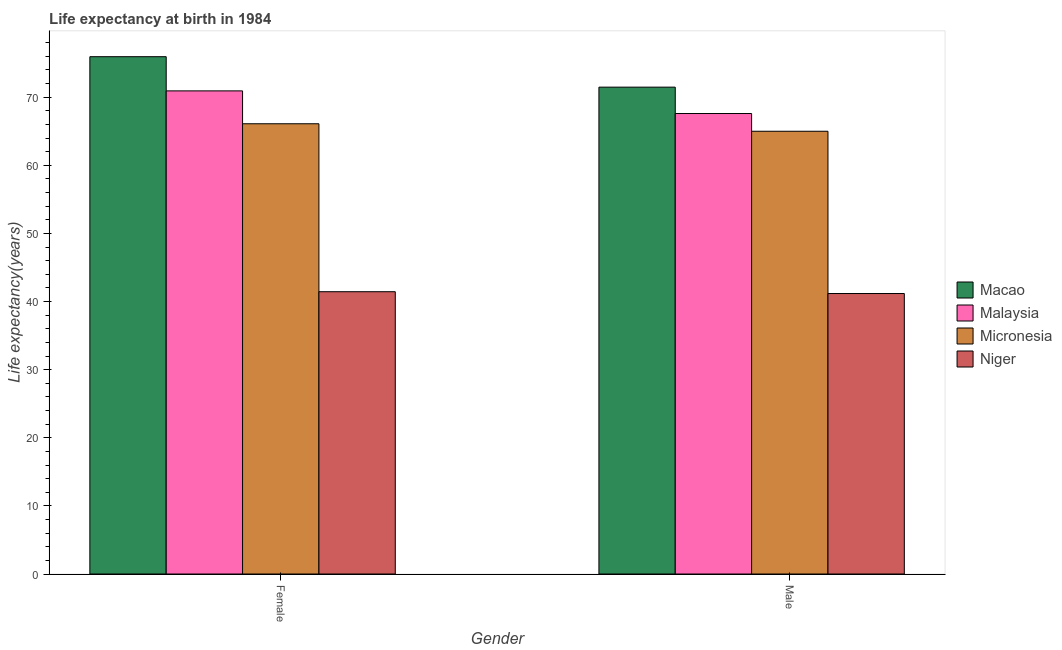How many different coloured bars are there?
Provide a succinct answer. 4. Are the number of bars on each tick of the X-axis equal?
Offer a terse response. Yes. How many bars are there on the 1st tick from the left?
Provide a succinct answer. 4. How many bars are there on the 2nd tick from the right?
Keep it short and to the point. 4. What is the label of the 2nd group of bars from the left?
Provide a succinct answer. Male. What is the life expectancy(male) in Niger?
Your answer should be compact. 41.18. Across all countries, what is the maximum life expectancy(female)?
Your answer should be compact. 75.95. Across all countries, what is the minimum life expectancy(female)?
Your answer should be very brief. 41.44. In which country was the life expectancy(male) maximum?
Provide a succinct answer. Macao. In which country was the life expectancy(male) minimum?
Your answer should be compact. Niger. What is the total life expectancy(male) in the graph?
Make the answer very short. 245.27. What is the difference between the life expectancy(male) in Macao and that in Micronesia?
Give a very brief answer. 6.48. What is the difference between the life expectancy(female) in Niger and the life expectancy(male) in Malaysia?
Offer a very short reply. -26.16. What is the average life expectancy(male) per country?
Keep it short and to the point. 61.32. What is the difference between the life expectancy(female) and life expectancy(male) in Micronesia?
Make the answer very short. 1.1. What is the ratio of the life expectancy(male) in Macao to that in Malaysia?
Provide a succinct answer. 1.06. What does the 3rd bar from the left in Male represents?
Your answer should be compact. Micronesia. What does the 4th bar from the right in Male represents?
Your answer should be compact. Macao. How many bars are there?
Your answer should be very brief. 8. Are all the bars in the graph horizontal?
Your answer should be very brief. No. Does the graph contain any zero values?
Your response must be concise. No. Does the graph contain grids?
Keep it short and to the point. No. Where does the legend appear in the graph?
Your answer should be compact. Center right. What is the title of the graph?
Your answer should be very brief. Life expectancy at birth in 1984. Does "Argentina" appear as one of the legend labels in the graph?
Keep it short and to the point. No. What is the label or title of the Y-axis?
Offer a very short reply. Life expectancy(years). What is the Life expectancy(years) in Macao in Female?
Ensure brevity in your answer.  75.95. What is the Life expectancy(years) in Malaysia in Female?
Give a very brief answer. 70.93. What is the Life expectancy(years) in Micronesia in Female?
Offer a very short reply. 66.1. What is the Life expectancy(years) of Niger in Female?
Make the answer very short. 41.44. What is the Life expectancy(years) in Macao in Male?
Provide a succinct answer. 71.48. What is the Life expectancy(years) of Malaysia in Male?
Provide a succinct answer. 67.61. What is the Life expectancy(years) in Micronesia in Male?
Provide a succinct answer. 65. What is the Life expectancy(years) in Niger in Male?
Give a very brief answer. 41.18. Across all Gender, what is the maximum Life expectancy(years) in Macao?
Your response must be concise. 75.95. Across all Gender, what is the maximum Life expectancy(years) in Malaysia?
Make the answer very short. 70.93. Across all Gender, what is the maximum Life expectancy(years) in Micronesia?
Keep it short and to the point. 66.1. Across all Gender, what is the maximum Life expectancy(years) of Niger?
Your answer should be very brief. 41.44. Across all Gender, what is the minimum Life expectancy(years) of Macao?
Provide a short and direct response. 71.48. Across all Gender, what is the minimum Life expectancy(years) of Malaysia?
Keep it short and to the point. 67.61. Across all Gender, what is the minimum Life expectancy(years) in Micronesia?
Give a very brief answer. 65. Across all Gender, what is the minimum Life expectancy(years) of Niger?
Your answer should be very brief. 41.18. What is the total Life expectancy(years) in Macao in the graph?
Your response must be concise. 147.43. What is the total Life expectancy(years) in Malaysia in the graph?
Your answer should be very brief. 138.54. What is the total Life expectancy(years) of Micronesia in the graph?
Your response must be concise. 131.11. What is the total Life expectancy(years) of Niger in the graph?
Keep it short and to the point. 82.62. What is the difference between the Life expectancy(years) in Macao in Female and that in Male?
Provide a short and direct response. 4.47. What is the difference between the Life expectancy(years) of Malaysia in Female and that in Male?
Provide a short and direct response. 3.32. What is the difference between the Life expectancy(years) of Micronesia in Female and that in Male?
Give a very brief answer. 1.1. What is the difference between the Life expectancy(years) of Niger in Female and that in Male?
Offer a very short reply. 0.27. What is the difference between the Life expectancy(years) of Macao in Female and the Life expectancy(years) of Malaysia in Male?
Provide a succinct answer. 8.34. What is the difference between the Life expectancy(years) of Macao in Female and the Life expectancy(years) of Micronesia in Male?
Give a very brief answer. 10.95. What is the difference between the Life expectancy(years) of Macao in Female and the Life expectancy(years) of Niger in Male?
Offer a terse response. 34.77. What is the difference between the Life expectancy(years) of Malaysia in Female and the Life expectancy(years) of Micronesia in Male?
Give a very brief answer. 5.93. What is the difference between the Life expectancy(years) in Malaysia in Female and the Life expectancy(years) in Niger in Male?
Ensure brevity in your answer.  29.75. What is the difference between the Life expectancy(years) in Micronesia in Female and the Life expectancy(years) in Niger in Male?
Provide a short and direct response. 24.92. What is the average Life expectancy(years) in Macao per Gender?
Provide a succinct answer. 73.71. What is the average Life expectancy(years) of Malaysia per Gender?
Your answer should be compact. 69.27. What is the average Life expectancy(years) in Micronesia per Gender?
Your answer should be very brief. 65.55. What is the average Life expectancy(years) of Niger per Gender?
Provide a short and direct response. 41.31. What is the difference between the Life expectancy(years) in Macao and Life expectancy(years) in Malaysia in Female?
Offer a terse response. 5.02. What is the difference between the Life expectancy(years) of Macao and Life expectancy(years) of Micronesia in Female?
Offer a very short reply. 9.85. What is the difference between the Life expectancy(years) in Macao and Life expectancy(years) in Niger in Female?
Offer a very short reply. 34.51. What is the difference between the Life expectancy(years) of Malaysia and Life expectancy(years) of Micronesia in Female?
Your response must be concise. 4.83. What is the difference between the Life expectancy(years) of Malaysia and Life expectancy(years) of Niger in Female?
Give a very brief answer. 29.49. What is the difference between the Life expectancy(years) in Micronesia and Life expectancy(years) in Niger in Female?
Your answer should be very brief. 24.66. What is the difference between the Life expectancy(years) of Macao and Life expectancy(years) of Malaysia in Male?
Provide a succinct answer. 3.87. What is the difference between the Life expectancy(years) in Macao and Life expectancy(years) in Micronesia in Male?
Provide a short and direct response. 6.48. What is the difference between the Life expectancy(years) of Macao and Life expectancy(years) of Niger in Male?
Give a very brief answer. 30.3. What is the difference between the Life expectancy(years) of Malaysia and Life expectancy(years) of Micronesia in Male?
Give a very brief answer. 2.6. What is the difference between the Life expectancy(years) of Malaysia and Life expectancy(years) of Niger in Male?
Make the answer very short. 26.43. What is the difference between the Life expectancy(years) of Micronesia and Life expectancy(years) of Niger in Male?
Keep it short and to the point. 23.82. What is the ratio of the Life expectancy(years) in Malaysia in Female to that in Male?
Offer a very short reply. 1.05. What is the ratio of the Life expectancy(years) in Micronesia in Female to that in Male?
Your answer should be compact. 1.02. What is the ratio of the Life expectancy(years) in Niger in Female to that in Male?
Offer a terse response. 1.01. What is the difference between the highest and the second highest Life expectancy(years) in Macao?
Offer a terse response. 4.47. What is the difference between the highest and the second highest Life expectancy(years) of Malaysia?
Offer a very short reply. 3.32. What is the difference between the highest and the second highest Life expectancy(years) in Niger?
Make the answer very short. 0.27. What is the difference between the highest and the lowest Life expectancy(years) of Macao?
Offer a terse response. 4.47. What is the difference between the highest and the lowest Life expectancy(years) in Malaysia?
Offer a terse response. 3.32. What is the difference between the highest and the lowest Life expectancy(years) in Micronesia?
Keep it short and to the point. 1.1. What is the difference between the highest and the lowest Life expectancy(years) in Niger?
Your answer should be very brief. 0.27. 